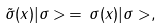<formula> <loc_0><loc_0><loc_500><loc_500>\tilde { \sigma } ( x ) | \sigma > \, = \, \sigma ( x ) | \sigma > ,</formula> 